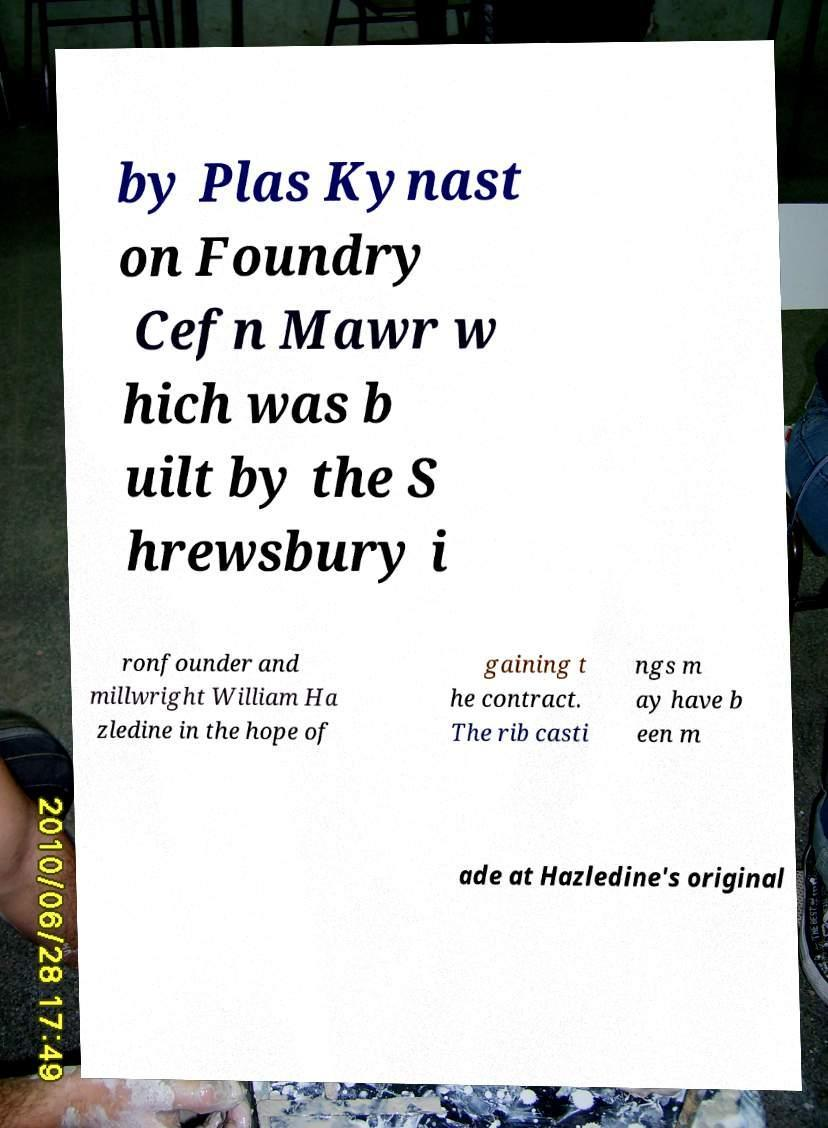What messages or text are displayed in this image? I need them in a readable, typed format. by Plas Kynast on Foundry Cefn Mawr w hich was b uilt by the S hrewsbury i ronfounder and millwright William Ha zledine in the hope of gaining t he contract. The rib casti ngs m ay have b een m ade at Hazledine's original 